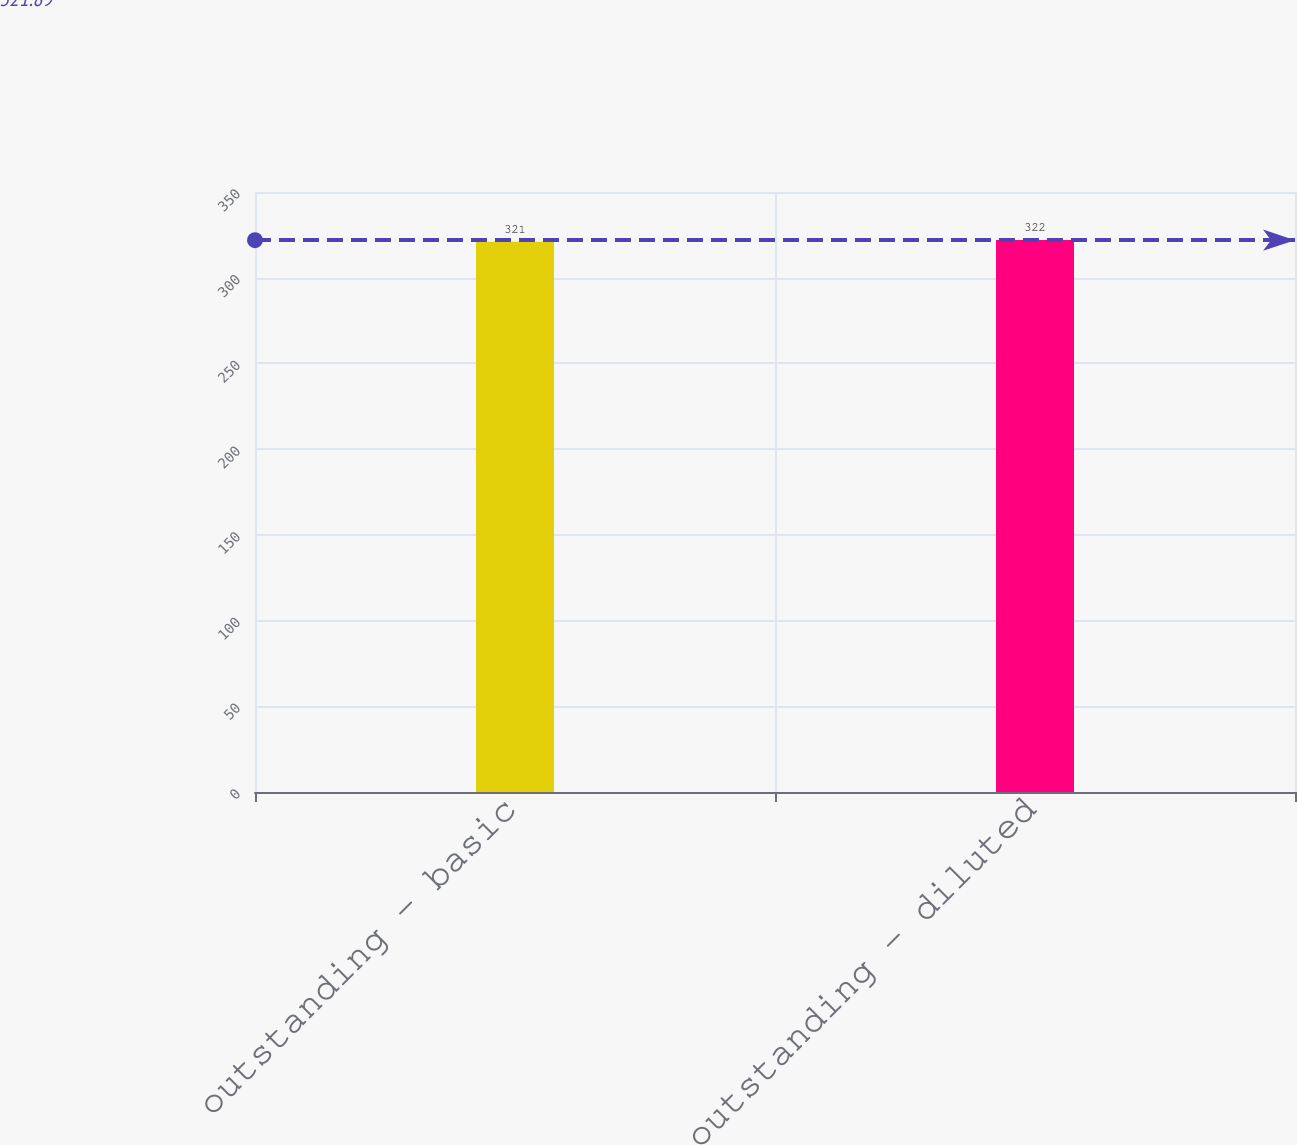Convert chart. <chart><loc_0><loc_0><loc_500><loc_500><bar_chart><fcel>outstanding - basic<fcel>outstanding - diluted<nl><fcel>321<fcel>322<nl></chart> 